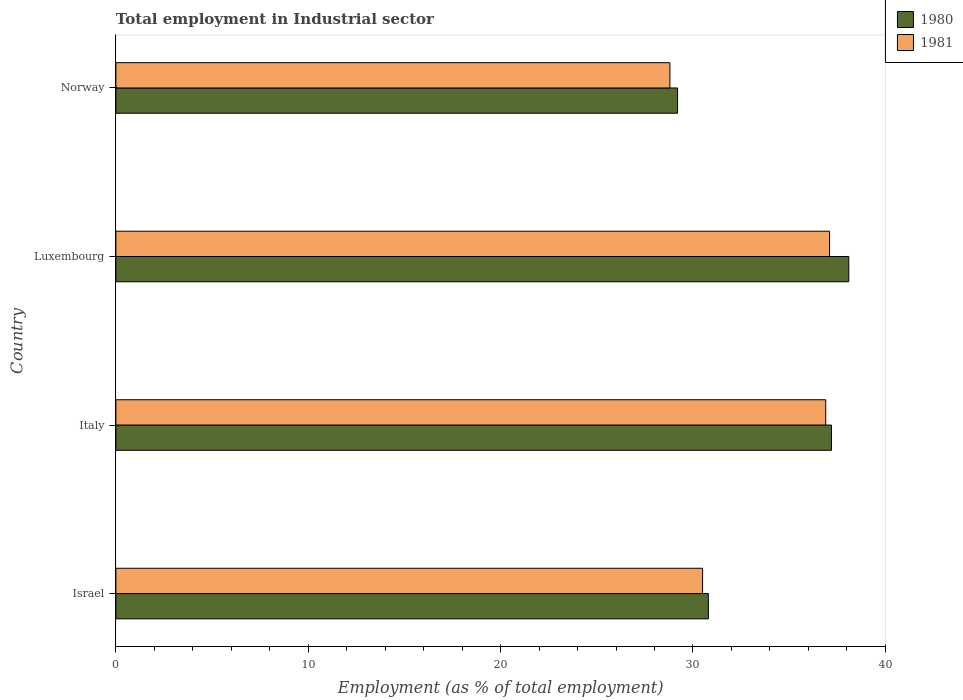How many groups of bars are there?
Keep it short and to the point. 4. Are the number of bars per tick equal to the number of legend labels?
Provide a succinct answer. Yes. Are the number of bars on each tick of the Y-axis equal?
Offer a very short reply. Yes. What is the label of the 3rd group of bars from the top?
Offer a terse response. Italy. In how many cases, is the number of bars for a given country not equal to the number of legend labels?
Make the answer very short. 0. What is the employment in industrial sector in 1980 in Luxembourg?
Your response must be concise. 38.1. Across all countries, what is the maximum employment in industrial sector in 1980?
Give a very brief answer. 38.1. Across all countries, what is the minimum employment in industrial sector in 1980?
Ensure brevity in your answer.  29.2. In which country was the employment in industrial sector in 1980 maximum?
Give a very brief answer. Luxembourg. In which country was the employment in industrial sector in 1980 minimum?
Offer a very short reply. Norway. What is the total employment in industrial sector in 1981 in the graph?
Your answer should be very brief. 133.3. What is the difference between the employment in industrial sector in 1981 in Luxembourg and that in Norway?
Give a very brief answer. 8.3. What is the difference between the employment in industrial sector in 1981 in Italy and the employment in industrial sector in 1980 in Norway?
Make the answer very short. 7.7. What is the average employment in industrial sector in 1981 per country?
Make the answer very short. 33.32. What is the difference between the employment in industrial sector in 1980 and employment in industrial sector in 1981 in Italy?
Your answer should be very brief. 0.3. What is the ratio of the employment in industrial sector in 1980 in Israel to that in Italy?
Give a very brief answer. 0.83. Is the employment in industrial sector in 1980 in Israel less than that in Luxembourg?
Ensure brevity in your answer.  Yes. What is the difference between the highest and the second highest employment in industrial sector in 1981?
Provide a short and direct response. 0.2. What is the difference between the highest and the lowest employment in industrial sector in 1981?
Your answer should be compact. 8.3. In how many countries, is the employment in industrial sector in 1981 greater than the average employment in industrial sector in 1981 taken over all countries?
Your answer should be compact. 2. What does the 1st bar from the top in Norway represents?
Your answer should be very brief. 1981. How many bars are there?
Your answer should be very brief. 8. Are all the bars in the graph horizontal?
Keep it short and to the point. Yes. What is the difference between two consecutive major ticks on the X-axis?
Your answer should be compact. 10. Are the values on the major ticks of X-axis written in scientific E-notation?
Provide a succinct answer. No. Does the graph contain any zero values?
Provide a short and direct response. No. Does the graph contain grids?
Keep it short and to the point. No. What is the title of the graph?
Your answer should be compact. Total employment in Industrial sector. Does "1995" appear as one of the legend labels in the graph?
Ensure brevity in your answer.  No. What is the label or title of the X-axis?
Offer a very short reply. Employment (as % of total employment). What is the label or title of the Y-axis?
Provide a short and direct response. Country. What is the Employment (as % of total employment) of 1980 in Israel?
Make the answer very short. 30.8. What is the Employment (as % of total employment) of 1981 in Israel?
Give a very brief answer. 30.5. What is the Employment (as % of total employment) of 1980 in Italy?
Make the answer very short. 37.2. What is the Employment (as % of total employment) of 1981 in Italy?
Offer a terse response. 36.9. What is the Employment (as % of total employment) of 1980 in Luxembourg?
Your answer should be very brief. 38.1. What is the Employment (as % of total employment) of 1981 in Luxembourg?
Give a very brief answer. 37.1. What is the Employment (as % of total employment) of 1980 in Norway?
Your answer should be compact. 29.2. What is the Employment (as % of total employment) of 1981 in Norway?
Make the answer very short. 28.8. Across all countries, what is the maximum Employment (as % of total employment) in 1980?
Your response must be concise. 38.1. Across all countries, what is the maximum Employment (as % of total employment) in 1981?
Your response must be concise. 37.1. Across all countries, what is the minimum Employment (as % of total employment) of 1980?
Keep it short and to the point. 29.2. Across all countries, what is the minimum Employment (as % of total employment) in 1981?
Provide a succinct answer. 28.8. What is the total Employment (as % of total employment) of 1980 in the graph?
Your answer should be compact. 135.3. What is the total Employment (as % of total employment) of 1981 in the graph?
Provide a succinct answer. 133.3. What is the difference between the Employment (as % of total employment) of 1981 in Israel and that in Italy?
Your answer should be very brief. -6.4. What is the difference between the Employment (as % of total employment) in 1980 in Israel and that in Norway?
Your answer should be compact. 1.6. What is the difference between the Employment (as % of total employment) in 1981 in Israel and that in Norway?
Give a very brief answer. 1.7. What is the difference between the Employment (as % of total employment) of 1980 in Italy and that in Luxembourg?
Offer a terse response. -0.9. What is the difference between the Employment (as % of total employment) of 1981 in Italy and that in Luxembourg?
Your answer should be compact. -0.2. What is the difference between the Employment (as % of total employment) in 1980 in Israel and the Employment (as % of total employment) in 1981 in Italy?
Your answer should be very brief. -6.1. What is the difference between the Employment (as % of total employment) of 1980 in Israel and the Employment (as % of total employment) of 1981 in Luxembourg?
Your answer should be very brief. -6.3. What is the average Employment (as % of total employment) of 1980 per country?
Ensure brevity in your answer.  33.83. What is the average Employment (as % of total employment) in 1981 per country?
Give a very brief answer. 33.33. What is the difference between the Employment (as % of total employment) of 1980 and Employment (as % of total employment) of 1981 in Israel?
Your answer should be very brief. 0.3. What is the difference between the Employment (as % of total employment) in 1980 and Employment (as % of total employment) in 1981 in Italy?
Make the answer very short. 0.3. What is the difference between the Employment (as % of total employment) of 1980 and Employment (as % of total employment) of 1981 in Norway?
Your answer should be compact. 0.4. What is the ratio of the Employment (as % of total employment) in 1980 in Israel to that in Italy?
Your answer should be very brief. 0.83. What is the ratio of the Employment (as % of total employment) of 1981 in Israel to that in Italy?
Provide a short and direct response. 0.83. What is the ratio of the Employment (as % of total employment) in 1980 in Israel to that in Luxembourg?
Offer a very short reply. 0.81. What is the ratio of the Employment (as % of total employment) in 1981 in Israel to that in Luxembourg?
Ensure brevity in your answer.  0.82. What is the ratio of the Employment (as % of total employment) of 1980 in Israel to that in Norway?
Provide a short and direct response. 1.05. What is the ratio of the Employment (as % of total employment) in 1981 in Israel to that in Norway?
Your answer should be very brief. 1.06. What is the ratio of the Employment (as % of total employment) in 1980 in Italy to that in Luxembourg?
Provide a short and direct response. 0.98. What is the ratio of the Employment (as % of total employment) in 1981 in Italy to that in Luxembourg?
Offer a very short reply. 0.99. What is the ratio of the Employment (as % of total employment) in 1980 in Italy to that in Norway?
Your answer should be very brief. 1.27. What is the ratio of the Employment (as % of total employment) of 1981 in Italy to that in Norway?
Your response must be concise. 1.28. What is the ratio of the Employment (as % of total employment) of 1980 in Luxembourg to that in Norway?
Keep it short and to the point. 1.3. What is the ratio of the Employment (as % of total employment) of 1981 in Luxembourg to that in Norway?
Offer a terse response. 1.29. What is the difference between the highest and the second highest Employment (as % of total employment) in 1980?
Your answer should be very brief. 0.9. What is the difference between the highest and the second highest Employment (as % of total employment) of 1981?
Your answer should be compact. 0.2. 